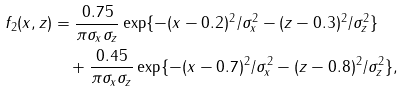<formula> <loc_0><loc_0><loc_500><loc_500>f _ { 2 } ( x , z ) & = \frac { 0 . 7 5 } { \pi \sigma _ { x } \sigma _ { z } } \exp \{ - ( x - 0 . 2 ) ^ { 2 } / \sigma _ { x } ^ { 2 } - ( z - 0 . 3 ) ^ { 2 } / \sigma _ { z } ^ { 2 } \} \\ & \quad + \frac { 0 . 4 5 } { \pi \sigma _ { x } \sigma _ { z } } \exp \{ - ( x - 0 . 7 ) ^ { 2 } / \sigma _ { x } ^ { 2 } - ( z - 0 . 8 ) ^ { 2 } / \sigma _ { z } ^ { 2 } \} ,</formula> 